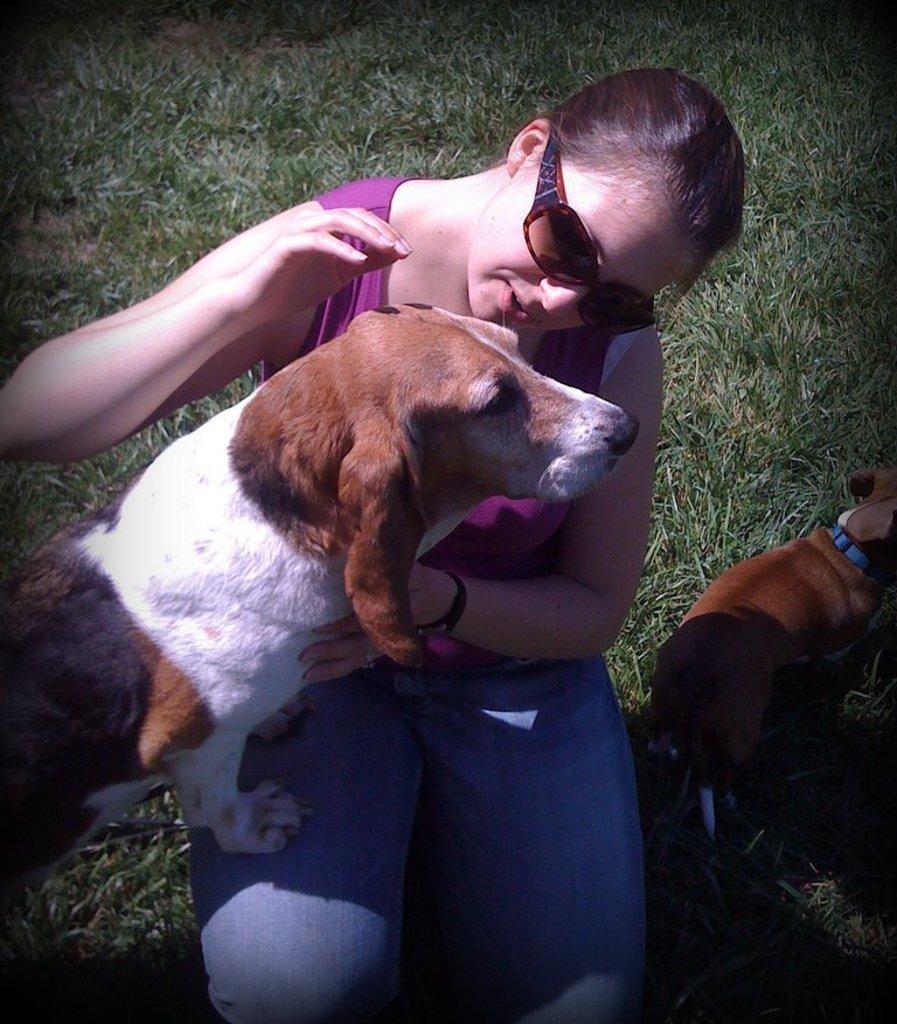Please provide a concise description of this image. In this image there is a lady sitting on grass and holding grass, beside her there is a puppy standing. 